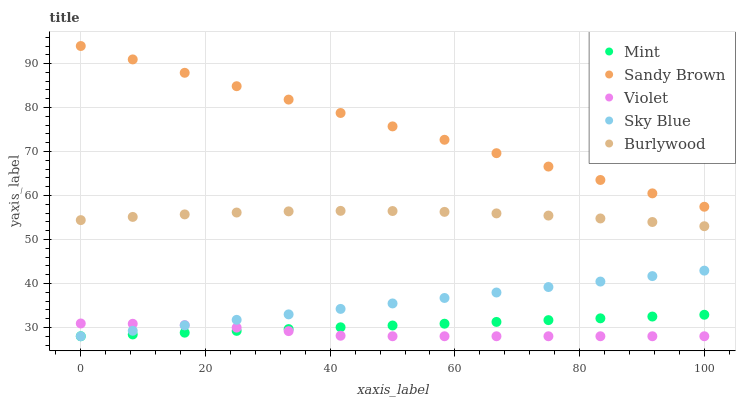Does Violet have the minimum area under the curve?
Answer yes or no. Yes. Does Sandy Brown have the maximum area under the curve?
Answer yes or no. Yes. Does Sky Blue have the minimum area under the curve?
Answer yes or no. No. Does Sky Blue have the maximum area under the curve?
Answer yes or no. No. Is Mint the smoothest?
Answer yes or no. Yes. Is Violet the roughest?
Answer yes or no. Yes. Is Sandy Brown the smoothest?
Answer yes or no. No. Is Sandy Brown the roughest?
Answer yes or no. No. Does Sky Blue have the lowest value?
Answer yes or no. Yes. Does Sandy Brown have the lowest value?
Answer yes or no. No. Does Sandy Brown have the highest value?
Answer yes or no. Yes. Does Sky Blue have the highest value?
Answer yes or no. No. Is Mint less than Sandy Brown?
Answer yes or no. Yes. Is Sandy Brown greater than Burlywood?
Answer yes or no. Yes. Does Sky Blue intersect Mint?
Answer yes or no. Yes. Is Sky Blue less than Mint?
Answer yes or no. No. Is Sky Blue greater than Mint?
Answer yes or no. No. Does Mint intersect Sandy Brown?
Answer yes or no. No. 